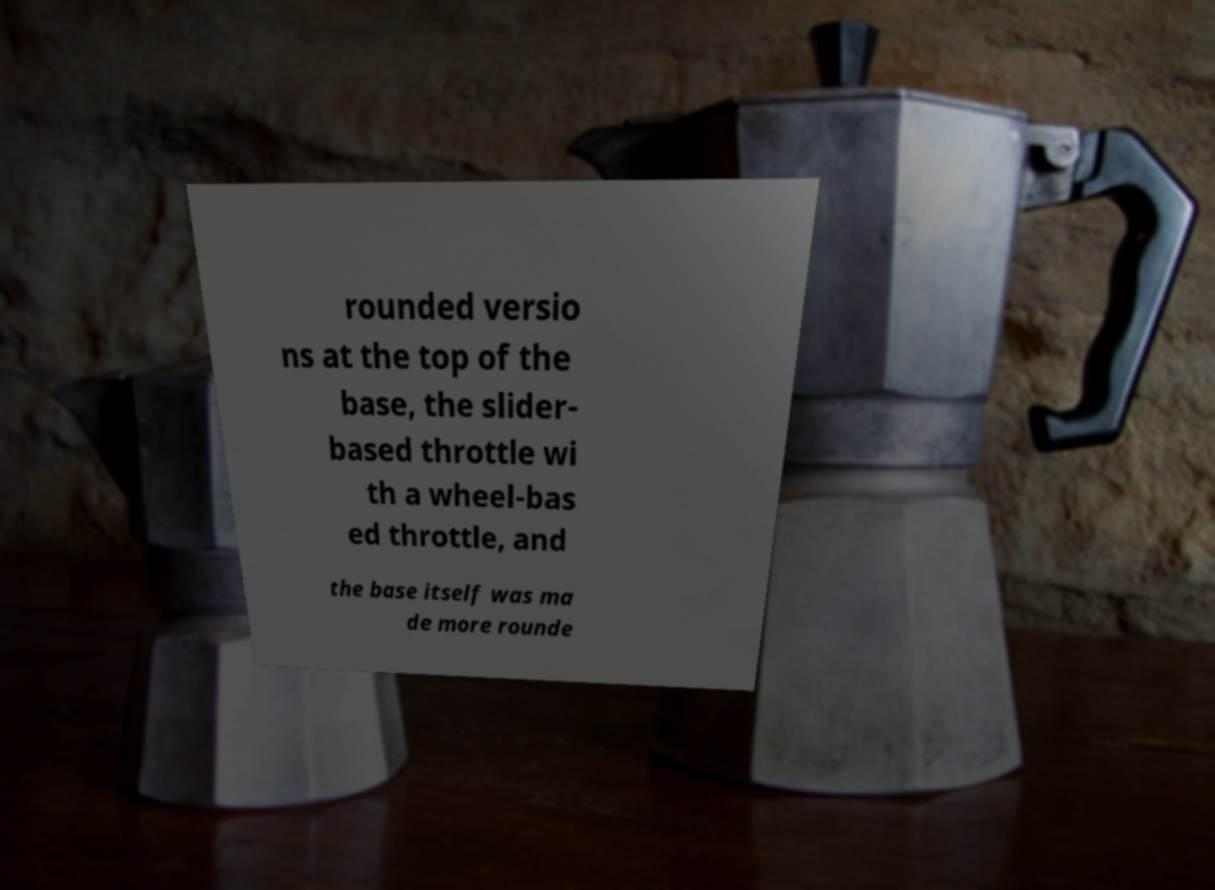Please identify and transcribe the text found in this image. rounded versio ns at the top of the base, the slider- based throttle wi th a wheel-bas ed throttle, and the base itself was ma de more rounde 